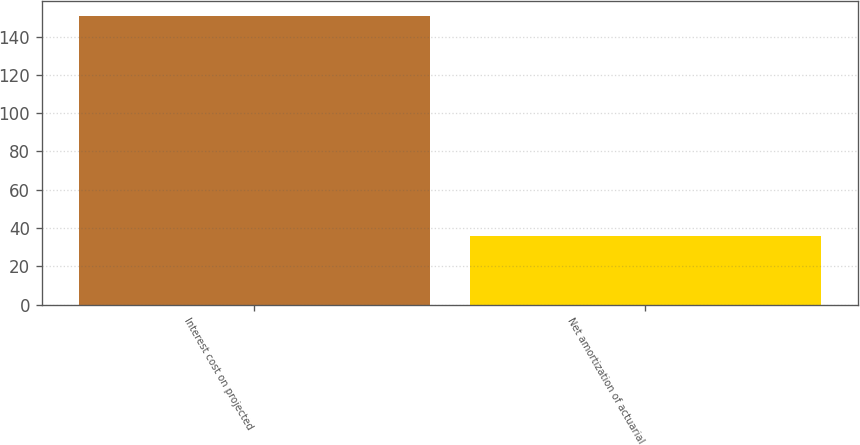Convert chart. <chart><loc_0><loc_0><loc_500><loc_500><bar_chart><fcel>Interest cost on projected<fcel>Net amortization of actuarial<nl><fcel>151<fcel>36<nl></chart> 